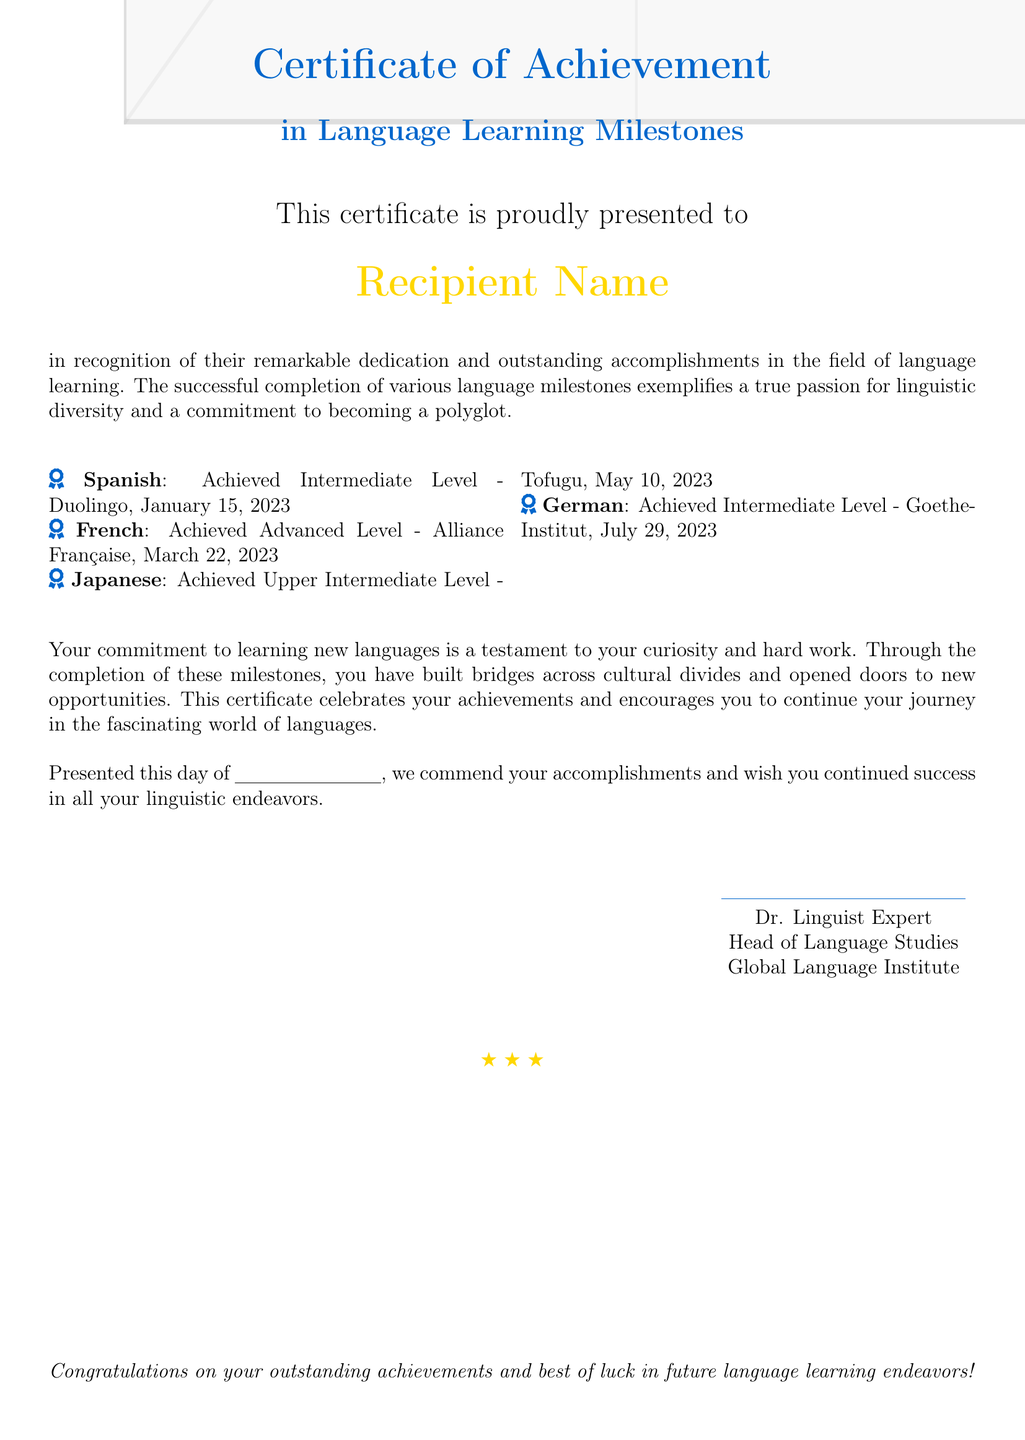What is the title of the certificate? The title of the certificate is presented in large font at the top of the document.
Answer: Certificate of Achievement Who is the recipient of the certificate? The recipient's name is displayed prominently in the center of the document.
Answer: Recipient Name What language has the highest achievement level on the certificate? The achievement levels for each language are listed; the highest is indicated for French.
Answer: Advanced Level What is the date when the German language milestone was achieved? The date for the German achievement is specifically indicated next to the milestone.
Answer: July 29, 2023 How many languages are listed on the certificate? The document contains a list of achievements in multiple languages.
Answer: Four What institution awarded the French language achievement? The institution that awarded the French achievement is mentioned directly in the document next to the milestone.
Answer: Alliance Française What is the profession of the individual who signed the certificate? The profession is noted in the signature section of the document.
Answer: Head of Language Studies What color is used for the background of the certificate? The background color is specified within the document settings and contents.
Answer: Gold What message is conveyed at the bottom of the certificate? This message celebrates the achievements and encourages future endeavors.
Answer: Congratulations on your outstanding achievements and best of luck in future language learning endeavors! 